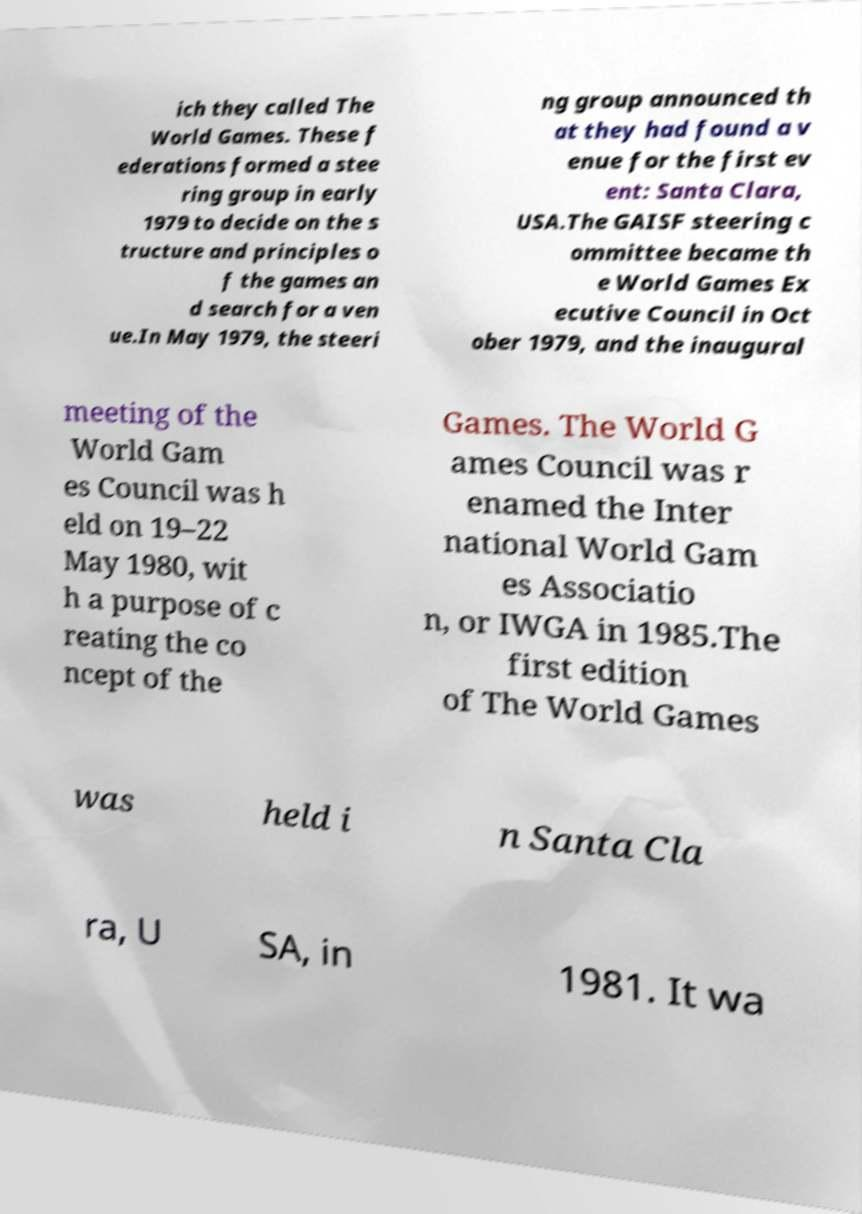Could you extract and type out the text from this image? ich they called The World Games. These f ederations formed a stee ring group in early 1979 to decide on the s tructure and principles o f the games an d search for a ven ue.In May 1979, the steeri ng group announced th at they had found a v enue for the first ev ent: Santa Clara, USA.The GAISF steering c ommittee became th e World Games Ex ecutive Council in Oct ober 1979, and the inaugural meeting of the World Gam es Council was h eld on 19–22 May 1980, wit h a purpose of c reating the co ncept of the Games. The World G ames Council was r enamed the Inter national World Gam es Associatio n, or IWGA in 1985.The first edition of The World Games was held i n Santa Cla ra, U SA, in 1981. It wa 